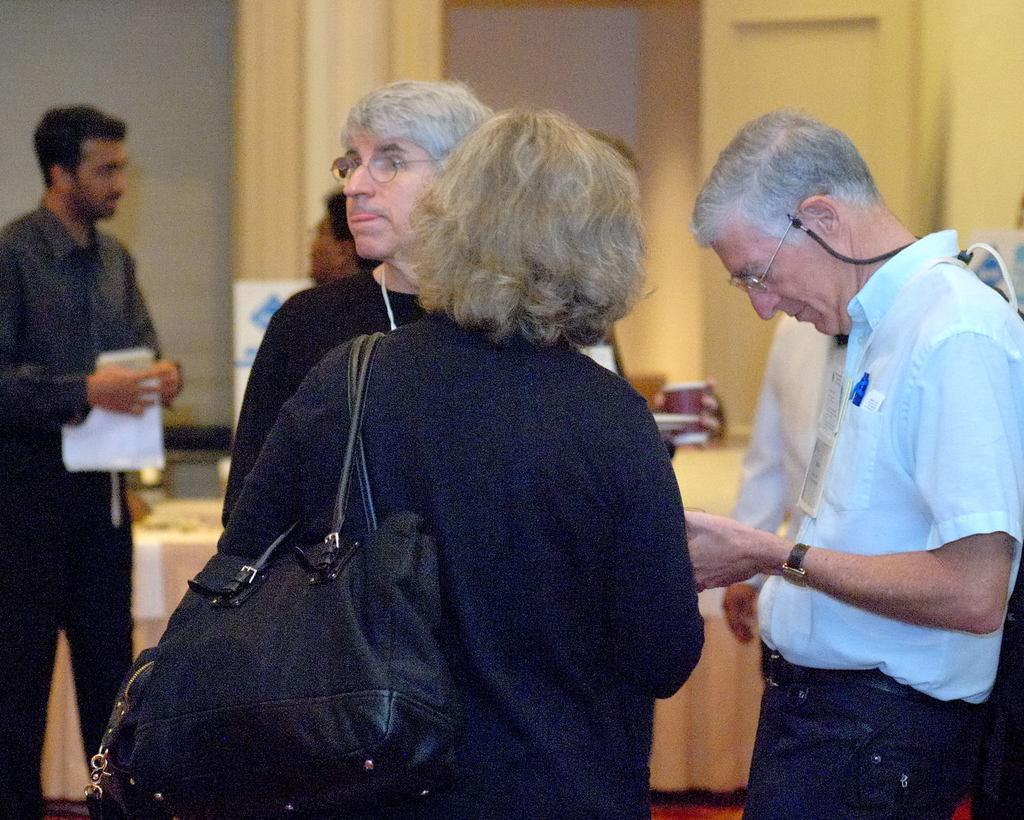How would you summarize this image in a sentence or two? This image consist of many people standing. It looks like a conference hall. In the front, the woman is wearing black dress and a black bag. To the right, the man is wearing sky blue shirt and blue jeans. In the background, there is a wall. 